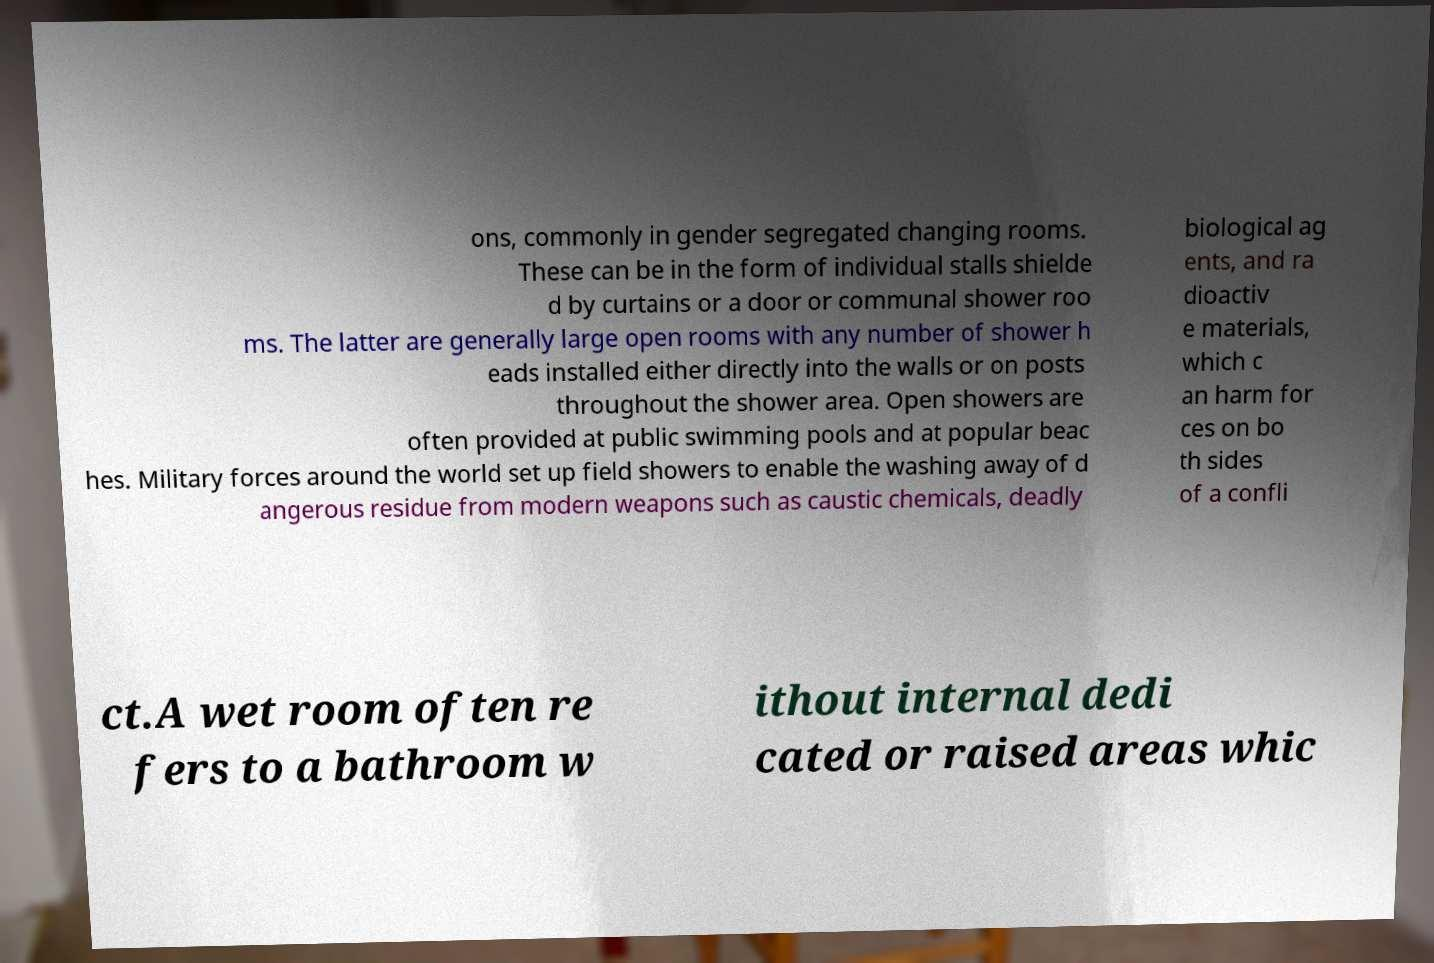Can you accurately transcribe the text from the provided image for me? ons, commonly in gender segregated changing rooms. These can be in the form of individual stalls shielde d by curtains or a door or communal shower roo ms. The latter are generally large open rooms with any number of shower h eads installed either directly into the walls or on posts throughout the shower area. Open showers are often provided at public swimming pools and at popular beac hes. Military forces around the world set up field showers to enable the washing away of d angerous residue from modern weapons such as caustic chemicals, deadly biological ag ents, and ra dioactiv e materials, which c an harm for ces on bo th sides of a confli ct.A wet room often re fers to a bathroom w ithout internal dedi cated or raised areas whic 